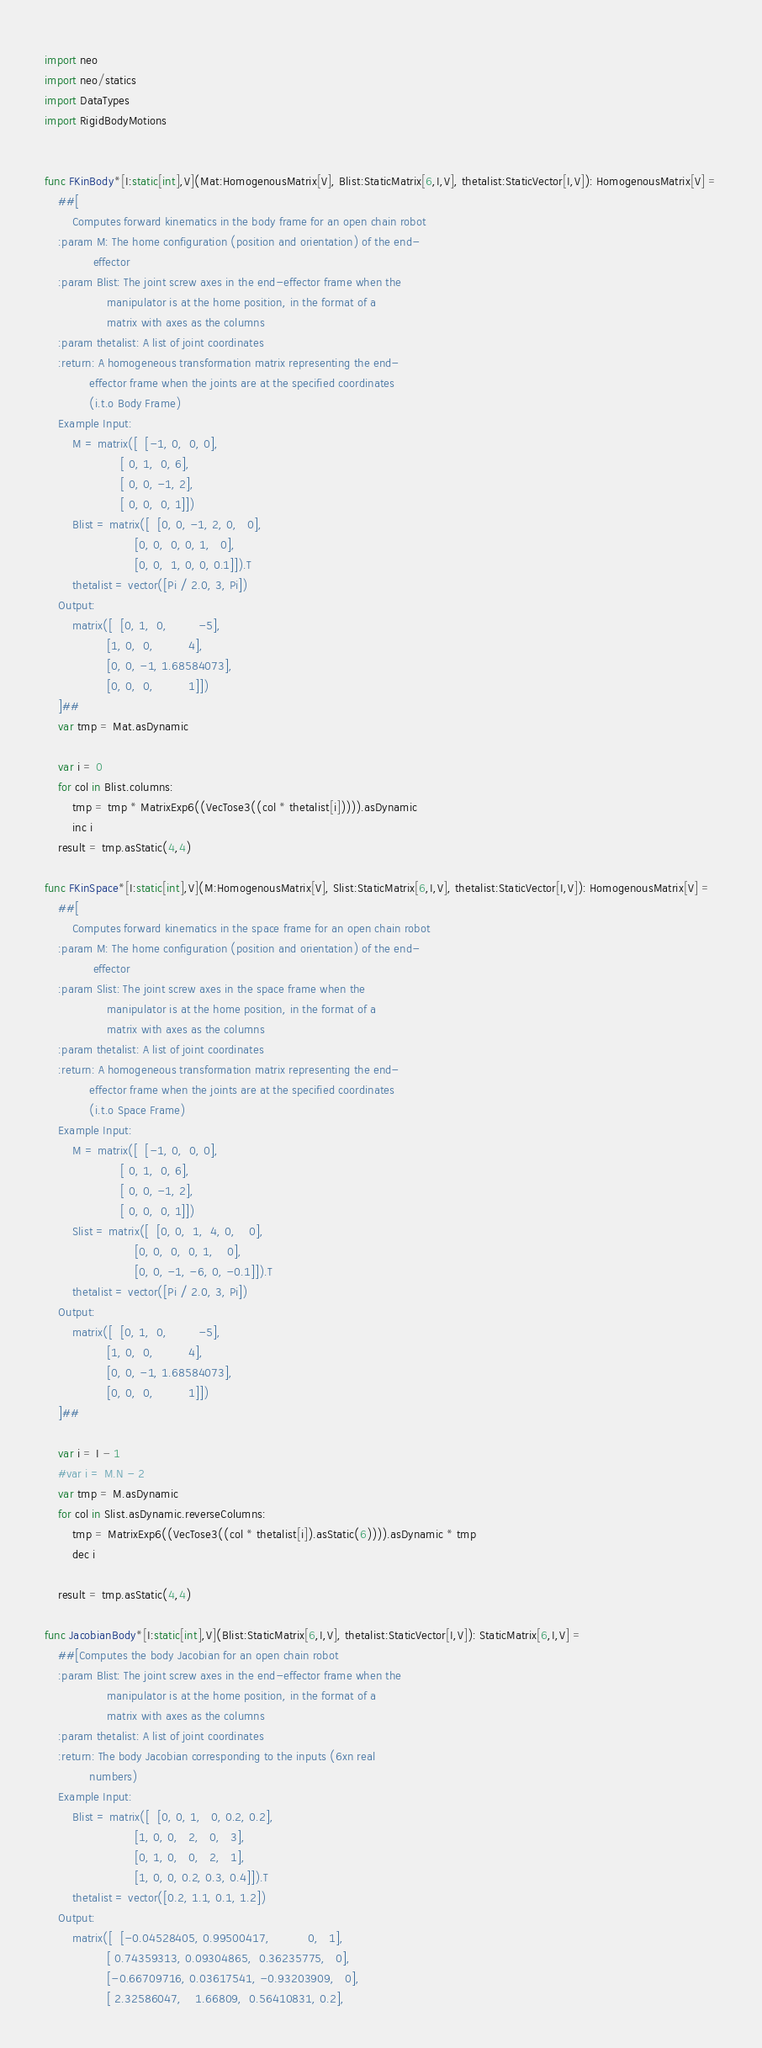Convert code to text. <code><loc_0><loc_0><loc_500><loc_500><_Nim_>import neo
import neo/statics
import DataTypes
import RigidBodyMotions


func FKinBody*[I:static[int],V](Mat:HomogenousMatrix[V], Blist:StaticMatrix[6,I,V], thetalist:StaticVector[I,V]): HomogenousMatrix[V] =
    ##[
        Computes forward kinematics in the body frame for an open chain robot
    :param M: The home configuration (position and orientation) of the end-
              effector
    :param Blist: The joint screw axes in the end-effector frame when the
                  manipulator is at the home position, in the format of a
                  matrix with axes as the columns
    :param thetalist: A list of joint coordinates
    :return: A homogeneous transformation matrix representing the end-
             effector frame when the joints are at the specified coordinates
             (i.t.o Body Frame)
    Example Input:
        M = matrix([  [-1, 0,  0, 0],
                      [ 0, 1,  0, 6],
                      [ 0, 0, -1, 2],
                      [ 0, 0,  0, 1]])
        Blist = matrix([  [0, 0, -1, 2, 0,   0],
                          [0, 0,  0, 0, 1,   0],
                          [0, 0,  1, 0, 0, 0.1]]).T
        thetalist = vector([Pi / 2.0, 3, Pi])
    Output:
        matrix([  [0, 1,  0,         -5],
                  [1, 0,  0,          4],
                  [0, 0, -1, 1.68584073],
                  [0, 0,  0,          1]])
    ]##
    var tmp = Mat.asDynamic
 
    var i = 0
    for col in Blist.columns:
        tmp = tmp * MatrixExp6((VecTose3((col * thetalist[i])))).asDynamic
        inc i
    result = tmp.asStatic(4,4)

func FKinSpace*[I:static[int],V](M:HomogenousMatrix[V], Slist:StaticMatrix[6,I,V], thetalist:StaticVector[I,V]): HomogenousMatrix[V] =
    ##[
        Computes forward kinematics in the space frame for an open chain robot
    :param M: The home configuration (position and orientation) of the end-
              effector
    :param Slist: The joint screw axes in the space frame when the
                  manipulator is at the home position, in the format of a
                  matrix with axes as the columns
    :param thetalist: A list of joint coordinates
    :return: A homogeneous transformation matrix representing the end-
             effector frame when the joints are at the specified coordinates
             (i.t.o Space Frame)
    Example Input:
        M = matrix([  [-1, 0,  0, 0],
                      [ 0, 1,  0, 6],
                      [ 0, 0, -1, 2],
                      [ 0, 0,  0, 1]])
        Slist = matrix([  [0, 0,  1,  4, 0,    0],
                          [0, 0,  0,  0, 1,    0],
                          [0, 0, -1, -6, 0, -0.1]]).T
        thetalist = vector([Pi / 2.0, 3, Pi])
    Output:
        matrix([  [0, 1,  0,         -5],
                  [1, 0,  0,          4],
                  [0, 0, -1, 1.68584073],
                  [0, 0,  0,          1]])
    ]##

    var i = I - 1
    #var i = M.N - 2
    var tmp = M.asDynamic
    for col in Slist.asDynamic.reverseColumns:
        tmp = MatrixExp6((VecTose3((col * thetalist[i]).asStatic(6)))).asDynamic * tmp
        dec i
    
    result = tmp.asStatic(4,4)

func JacobianBody*[I:static[int],V](Blist:StaticMatrix[6,I,V], thetalist:StaticVector[I,V]): StaticMatrix[6,I,V] =
    ##[Computes the body Jacobian for an open chain robot
    :param Blist: The joint screw axes in the end-effector frame when the
                  manipulator is at the home position, in the format of a
                  matrix with axes as the columns
    :param thetalist: A list of joint coordinates
    :return: The body Jacobian corresponding to the inputs (6xn real
             numbers)
    Example Input:
        Blist = matrix([  [0, 0, 1,   0, 0.2, 0.2],
                          [1, 0, 0,   2,   0,   3],
                          [0, 1, 0,   0,   2,   1],
                          [1, 0, 0, 0.2, 0.3, 0.4]]).T
        thetalist = vector([0.2, 1.1, 0.1, 1.2])
    Output:
        matrix([  [-0.04528405, 0.99500417,           0,   1],
                  [ 0.74359313, 0.09304865,  0.36235775,   0],
                  [-0.66709716, 0.03617541, -0.93203909,   0],
                  [ 2.32586047,    1.66809,  0.56410831, 0.2],</code> 